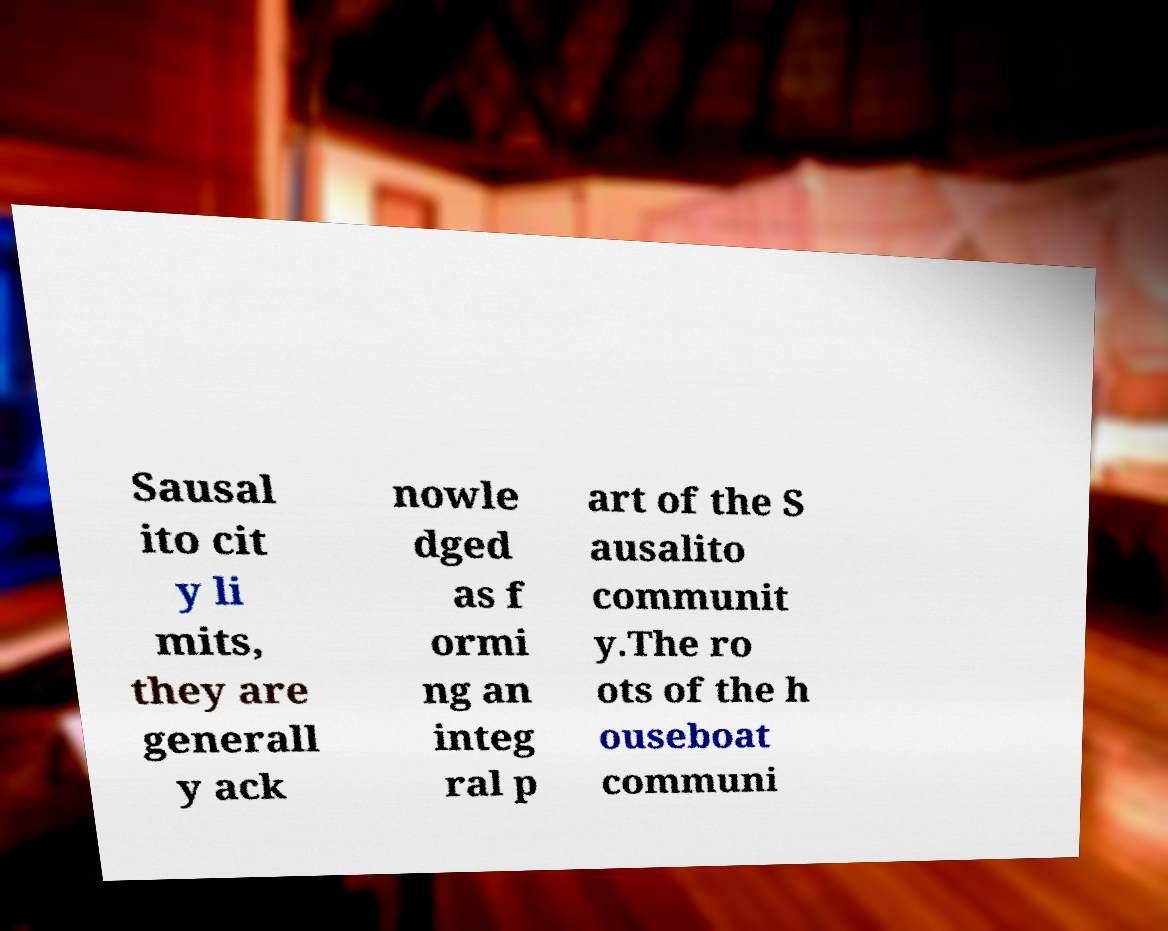Can you accurately transcribe the text from the provided image for me? Sausal ito cit y li mits, they are generall y ack nowle dged as f ormi ng an integ ral p art of the S ausalito communit y.The ro ots of the h ouseboat communi 